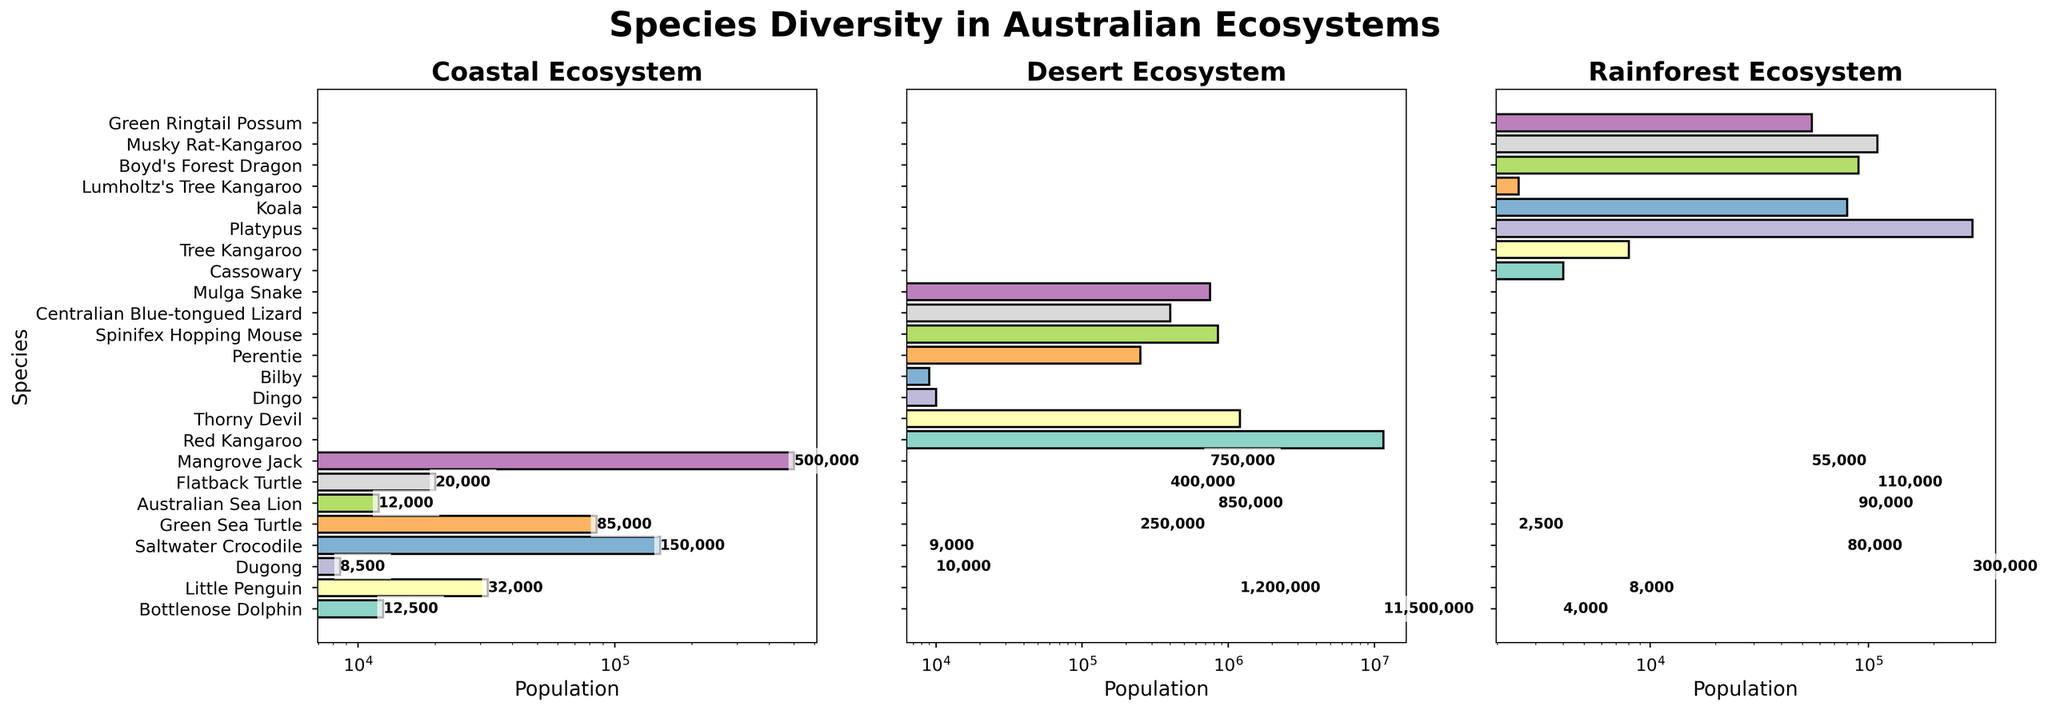What is the species with the highest population in the Coastal ecosystem? The highest bar in the Coastal ecosystem subplot represents the Saltwater Crocodile with a population of 150,000.
Answer: Saltwater Crocodile Which species in the Rainforest ecosystem has the lowest population, and what is its population? The shortest bar in the Rainforest ecosystem subplot represents Lumholtz's Tree Kangaroo with a population of 2,500.
Answer: Lumholtz's Tree Kangaroo, 2,500 How does the population of the Red Kangaroo in the Desert ecosystem compare to that of the Green Sea Turtle in the Coastal ecosystem? The Red Kangaroo has a population of 11,500,000, which is significantly higher than the Green Sea Turtle's population of 85,000 in the Coastal ecosystem.
Answer: Red Kangaroo is much higher What is the total population of species in the Rainforest ecosystem? By adding the populations of all species in the Rainforest ecosystem (4000 + 8000 + 300000 + 80000 + 2500 + 90000 + 110000 + 55000), the total is 643,500.
Answer: 643,500 Are there any species with a population between 10,000 and 20,000 in the Coastal ecosystem? If so, name them. Reviewing the bars in the Coastal ecosystem, the Australian Sea Lion has a population of 12,000 and the Flatback Turtle has 20,000.
Answer: Australian Sea Lion, Flatback Turtle Which species has the second-largest population in the Desert ecosystem? The second tallest bar in the Desert ecosystem subplot is for the Mulga Snake, with a population of 750,000.
Answer: Mulga Snake In which ecosystem can you find the highest population species among all three ecosystems? Comparing the tallest bar in all three subplots, the Red Kangaroo in the Desert ecosystem has the highest population of 11,500,000.
Answer: Desert ecosystem Calculate the average population of species in the Coastal ecosystem. Summing up the populations in the Coastal ecosystem (12500 + 32000 + 8500 + 150000 + 85000 + 12000 + 20000 + 500000) equals 799,000. Dividing by the number of species (8) gives an average of 99,875.
Answer: 99,875 Which ecosystems have species with populations represented on a logarithmic scale? Each ecosystem subplot uses a log scale on the x-axis to display species populations, as indicated by the titles and scales on the figure.
Answer: All ecosystems Comparing the total populations of species in the Desert and Rainforest ecosystems, which one is higher and by how much? Summing the populations in the Desert (11500000 + 1200000 + 10000 + 9000 + 250000 + 850000 + 400000 + 750000) equals 15,860,000. The Rainforest total is 643,500. 15,860,000 - 643,500 = 15,216,500.
Answer: Desert by 15,216,500 